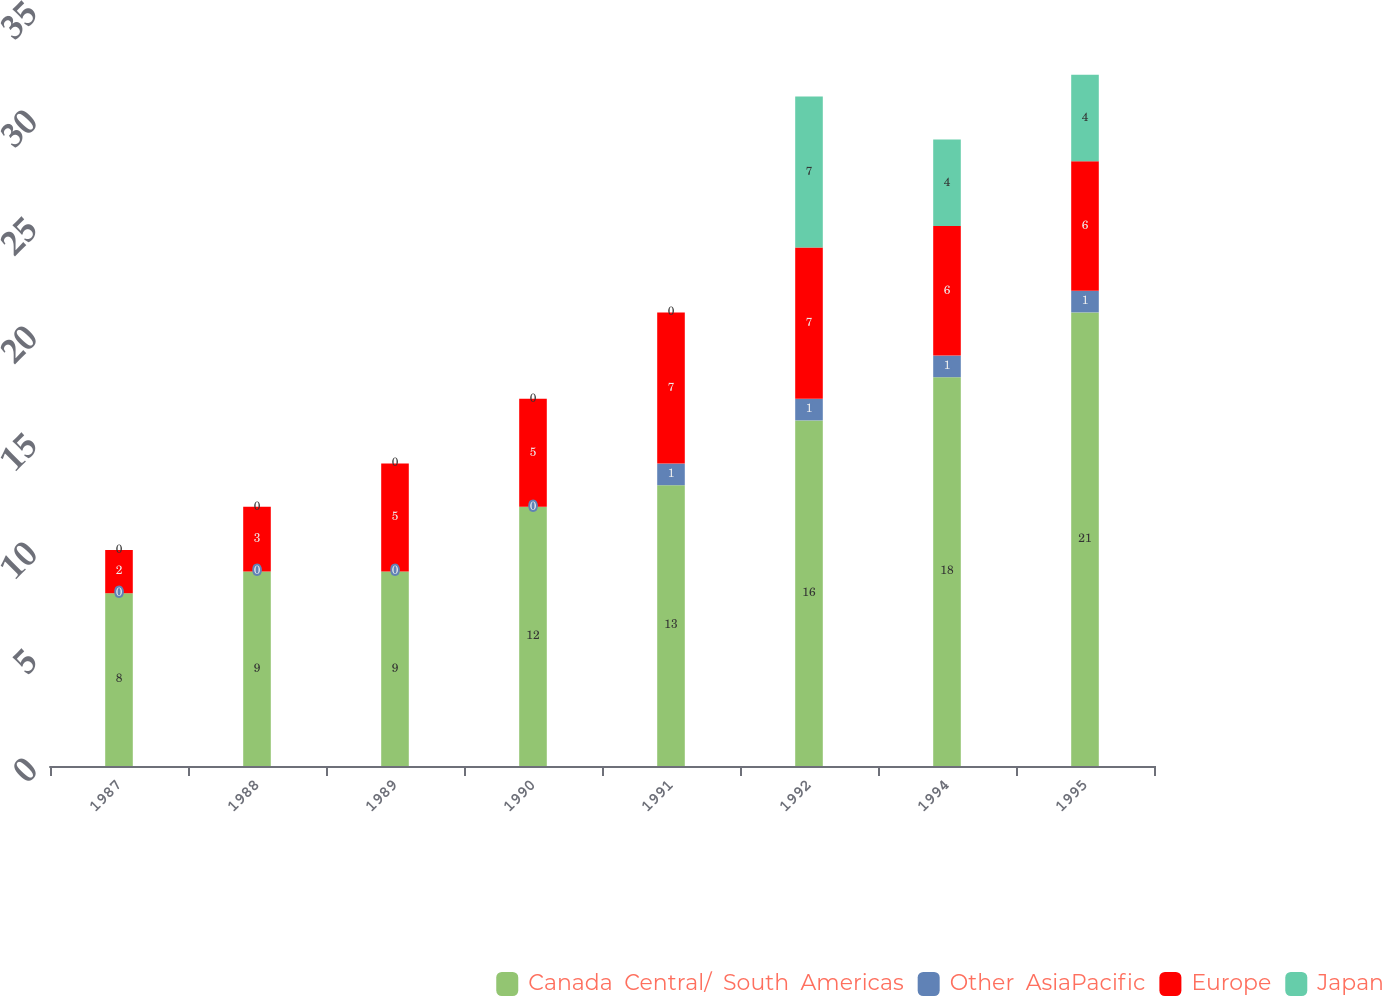Convert chart to OTSL. <chart><loc_0><loc_0><loc_500><loc_500><stacked_bar_chart><ecel><fcel>1987<fcel>1988<fcel>1989<fcel>1990<fcel>1991<fcel>1992<fcel>1994<fcel>1995<nl><fcel>Canada  Central/  South  Americas<fcel>8<fcel>9<fcel>9<fcel>12<fcel>13<fcel>16<fcel>18<fcel>21<nl><fcel>Other  AsiaPacific<fcel>0<fcel>0<fcel>0<fcel>0<fcel>1<fcel>1<fcel>1<fcel>1<nl><fcel>Europe<fcel>2<fcel>3<fcel>5<fcel>5<fcel>7<fcel>7<fcel>6<fcel>6<nl><fcel>Japan<fcel>0<fcel>0<fcel>0<fcel>0<fcel>0<fcel>7<fcel>4<fcel>4<nl></chart> 